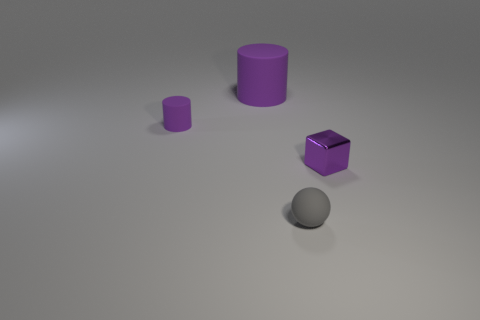Add 2 purple cubes. How many objects exist? 6 Subtract all balls. How many objects are left? 3 Subtract 0 red cubes. How many objects are left? 4 Subtract all cylinders. Subtract all gray matte balls. How many objects are left? 1 Add 4 tiny gray balls. How many tiny gray balls are left? 5 Add 2 big purple things. How many big purple things exist? 3 